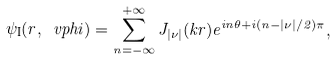<formula> <loc_0><loc_0><loc_500><loc_500>\psi _ { \text {I} } ( r , \ v p h i ) = \sum _ { n = - \infty } ^ { + \infty } J _ { | \nu | } ( k r ) e ^ { i n \theta + i ( n - | \nu | / 2 ) \pi } ,</formula> 